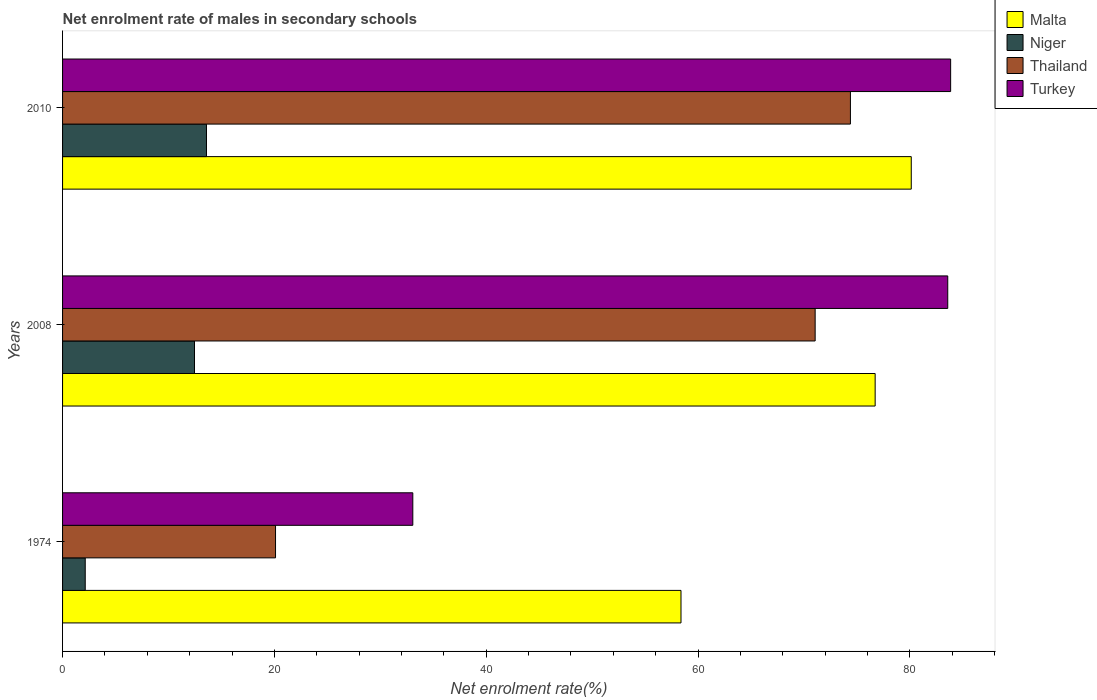How many different coloured bars are there?
Provide a succinct answer. 4. How many groups of bars are there?
Offer a very short reply. 3. Are the number of bars per tick equal to the number of legend labels?
Make the answer very short. Yes. How many bars are there on the 1st tick from the top?
Make the answer very short. 4. How many bars are there on the 2nd tick from the bottom?
Your answer should be very brief. 4. What is the label of the 3rd group of bars from the top?
Your answer should be compact. 1974. What is the net enrolment rate of males in secondary schools in Thailand in 2010?
Ensure brevity in your answer.  74.39. Across all years, what is the maximum net enrolment rate of males in secondary schools in Turkey?
Provide a short and direct response. 83.85. Across all years, what is the minimum net enrolment rate of males in secondary schools in Thailand?
Provide a short and direct response. 20.11. In which year was the net enrolment rate of males in secondary schools in Malta minimum?
Give a very brief answer. 1974. What is the total net enrolment rate of males in secondary schools in Turkey in the graph?
Keep it short and to the point. 200.51. What is the difference between the net enrolment rate of males in secondary schools in Thailand in 2008 and that in 2010?
Offer a terse response. -3.33. What is the difference between the net enrolment rate of males in secondary schools in Malta in 2010 and the net enrolment rate of males in secondary schools in Niger in 1974?
Give a very brief answer. 78. What is the average net enrolment rate of males in secondary schools in Malta per year?
Your answer should be compact. 71.75. In the year 1974, what is the difference between the net enrolment rate of males in secondary schools in Thailand and net enrolment rate of males in secondary schools in Malta?
Give a very brief answer. -38.29. In how many years, is the net enrolment rate of males in secondary schools in Malta greater than 8 %?
Offer a very short reply. 3. What is the ratio of the net enrolment rate of males in secondary schools in Thailand in 2008 to that in 2010?
Your answer should be very brief. 0.96. Is the net enrolment rate of males in secondary schools in Malta in 1974 less than that in 2008?
Provide a succinct answer. Yes. Is the difference between the net enrolment rate of males in secondary schools in Thailand in 1974 and 2008 greater than the difference between the net enrolment rate of males in secondary schools in Malta in 1974 and 2008?
Make the answer very short. No. What is the difference between the highest and the second highest net enrolment rate of males in secondary schools in Thailand?
Provide a succinct answer. 3.33. What is the difference between the highest and the lowest net enrolment rate of males in secondary schools in Turkey?
Your answer should be very brief. 50.78. Is the sum of the net enrolment rate of males in secondary schools in Niger in 1974 and 2008 greater than the maximum net enrolment rate of males in secondary schools in Turkey across all years?
Ensure brevity in your answer.  No. What does the 2nd bar from the top in 2010 represents?
Keep it short and to the point. Thailand. What does the 2nd bar from the bottom in 1974 represents?
Offer a very short reply. Niger. Is it the case that in every year, the sum of the net enrolment rate of males in secondary schools in Thailand and net enrolment rate of males in secondary schools in Turkey is greater than the net enrolment rate of males in secondary schools in Malta?
Provide a succinct answer. No. Are all the bars in the graph horizontal?
Offer a terse response. Yes. What is the difference between two consecutive major ticks on the X-axis?
Give a very brief answer. 20. Are the values on the major ticks of X-axis written in scientific E-notation?
Provide a succinct answer. No. Does the graph contain any zero values?
Offer a very short reply. No. Where does the legend appear in the graph?
Make the answer very short. Top right. What is the title of the graph?
Provide a short and direct response. Net enrolment rate of males in secondary schools. Does "Equatorial Guinea" appear as one of the legend labels in the graph?
Offer a terse response. No. What is the label or title of the X-axis?
Your answer should be very brief. Net enrolment rate(%). What is the Net enrolment rate(%) of Malta in 1974?
Offer a very short reply. 58.39. What is the Net enrolment rate(%) in Niger in 1974?
Offer a terse response. 2.14. What is the Net enrolment rate(%) of Thailand in 1974?
Provide a succinct answer. 20.11. What is the Net enrolment rate(%) of Turkey in 1974?
Offer a very short reply. 33.07. What is the Net enrolment rate(%) in Malta in 2008?
Your answer should be very brief. 76.73. What is the Net enrolment rate(%) in Niger in 2008?
Your response must be concise. 12.46. What is the Net enrolment rate(%) in Thailand in 2008?
Offer a very short reply. 71.06. What is the Net enrolment rate(%) of Turkey in 2008?
Provide a succinct answer. 83.58. What is the Net enrolment rate(%) in Malta in 2010?
Ensure brevity in your answer.  80.14. What is the Net enrolment rate(%) of Niger in 2010?
Make the answer very short. 13.59. What is the Net enrolment rate(%) in Thailand in 2010?
Make the answer very short. 74.39. What is the Net enrolment rate(%) in Turkey in 2010?
Provide a short and direct response. 83.85. Across all years, what is the maximum Net enrolment rate(%) in Malta?
Give a very brief answer. 80.14. Across all years, what is the maximum Net enrolment rate(%) in Niger?
Keep it short and to the point. 13.59. Across all years, what is the maximum Net enrolment rate(%) in Thailand?
Provide a short and direct response. 74.39. Across all years, what is the maximum Net enrolment rate(%) in Turkey?
Your answer should be compact. 83.85. Across all years, what is the minimum Net enrolment rate(%) of Malta?
Give a very brief answer. 58.39. Across all years, what is the minimum Net enrolment rate(%) of Niger?
Ensure brevity in your answer.  2.14. Across all years, what is the minimum Net enrolment rate(%) of Thailand?
Your answer should be very brief. 20.11. Across all years, what is the minimum Net enrolment rate(%) of Turkey?
Offer a very short reply. 33.07. What is the total Net enrolment rate(%) of Malta in the graph?
Your response must be concise. 215.26. What is the total Net enrolment rate(%) of Niger in the graph?
Make the answer very short. 28.19. What is the total Net enrolment rate(%) of Thailand in the graph?
Make the answer very short. 165.56. What is the total Net enrolment rate(%) of Turkey in the graph?
Your answer should be very brief. 200.51. What is the difference between the Net enrolment rate(%) of Malta in 1974 and that in 2008?
Give a very brief answer. -18.33. What is the difference between the Net enrolment rate(%) of Niger in 1974 and that in 2008?
Your response must be concise. -10.32. What is the difference between the Net enrolment rate(%) of Thailand in 1974 and that in 2008?
Offer a very short reply. -50.95. What is the difference between the Net enrolment rate(%) of Turkey in 1974 and that in 2008?
Your answer should be compact. -50.51. What is the difference between the Net enrolment rate(%) in Malta in 1974 and that in 2010?
Keep it short and to the point. -21.74. What is the difference between the Net enrolment rate(%) of Niger in 1974 and that in 2010?
Offer a terse response. -11.45. What is the difference between the Net enrolment rate(%) in Thailand in 1974 and that in 2010?
Provide a succinct answer. -54.28. What is the difference between the Net enrolment rate(%) of Turkey in 1974 and that in 2010?
Give a very brief answer. -50.78. What is the difference between the Net enrolment rate(%) of Malta in 2008 and that in 2010?
Ensure brevity in your answer.  -3.41. What is the difference between the Net enrolment rate(%) of Niger in 2008 and that in 2010?
Your response must be concise. -1.13. What is the difference between the Net enrolment rate(%) of Thailand in 2008 and that in 2010?
Keep it short and to the point. -3.33. What is the difference between the Net enrolment rate(%) of Turkey in 2008 and that in 2010?
Provide a short and direct response. -0.27. What is the difference between the Net enrolment rate(%) in Malta in 1974 and the Net enrolment rate(%) in Niger in 2008?
Offer a terse response. 45.94. What is the difference between the Net enrolment rate(%) of Malta in 1974 and the Net enrolment rate(%) of Thailand in 2008?
Keep it short and to the point. -12.67. What is the difference between the Net enrolment rate(%) of Malta in 1974 and the Net enrolment rate(%) of Turkey in 2008?
Your answer should be compact. -25.19. What is the difference between the Net enrolment rate(%) in Niger in 1974 and the Net enrolment rate(%) in Thailand in 2008?
Make the answer very short. -68.92. What is the difference between the Net enrolment rate(%) of Niger in 1974 and the Net enrolment rate(%) of Turkey in 2008?
Provide a succinct answer. -81.44. What is the difference between the Net enrolment rate(%) in Thailand in 1974 and the Net enrolment rate(%) in Turkey in 2008?
Make the answer very short. -63.47. What is the difference between the Net enrolment rate(%) of Malta in 1974 and the Net enrolment rate(%) of Niger in 2010?
Make the answer very short. 44.81. What is the difference between the Net enrolment rate(%) in Malta in 1974 and the Net enrolment rate(%) in Thailand in 2010?
Your response must be concise. -16. What is the difference between the Net enrolment rate(%) of Malta in 1974 and the Net enrolment rate(%) of Turkey in 2010?
Make the answer very short. -25.46. What is the difference between the Net enrolment rate(%) of Niger in 1974 and the Net enrolment rate(%) of Thailand in 2010?
Give a very brief answer. -72.25. What is the difference between the Net enrolment rate(%) in Niger in 1974 and the Net enrolment rate(%) in Turkey in 2010?
Make the answer very short. -81.71. What is the difference between the Net enrolment rate(%) in Thailand in 1974 and the Net enrolment rate(%) in Turkey in 2010?
Provide a short and direct response. -63.75. What is the difference between the Net enrolment rate(%) in Malta in 2008 and the Net enrolment rate(%) in Niger in 2010?
Keep it short and to the point. 63.14. What is the difference between the Net enrolment rate(%) of Malta in 2008 and the Net enrolment rate(%) of Thailand in 2010?
Your response must be concise. 2.33. What is the difference between the Net enrolment rate(%) in Malta in 2008 and the Net enrolment rate(%) in Turkey in 2010?
Give a very brief answer. -7.13. What is the difference between the Net enrolment rate(%) in Niger in 2008 and the Net enrolment rate(%) in Thailand in 2010?
Give a very brief answer. -61.94. What is the difference between the Net enrolment rate(%) in Niger in 2008 and the Net enrolment rate(%) in Turkey in 2010?
Provide a short and direct response. -71.4. What is the difference between the Net enrolment rate(%) of Thailand in 2008 and the Net enrolment rate(%) of Turkey in 2010?
Your response must be concise. -12.79. What is the average Net enrolment rate(%) of Malta per year?
Ensure brevity in your answer.  71.75. What is the average Net enrolment rate(%) of Niger per year?
Keep it short and to the point. 9.4. What is the average Net enrolment rate(%) in Thailand per year?
Make the answer very short. 55.19. What is the average Net enrolment rate(%) of Turkey per year?
Offer a very short reply. 66.84. In the year 1974, what is the difference between the Net enrolment rate(%) of Malta and Net enrolment rate(%) of Niger?
Offer a terse response. 56.25. In the year 1974, what is the difference between the Net enrolment rate(%) in Malta and Net enrolment rate(%) in Thailand?
Give a very brief answer. 38.29. In the year 1974, what is the difference between the Net enrolment rate(%) in Malta and Net enrolment rate(%) in Turkey?
Make the answer very short. 25.32. In the year 1974, what is the difference between the Net enrolment rate(%) in Niger and Net enrolment rate(%) in Thailand?
Make the answer very short. -17.97. In the year 1974, what is the difference between the Net enrolment rate(%) in Niger and Net enrolment rate(%) in Turkey?
Make the answer very short. -30.93. In the year 1974, what is the difference between the Net enrolment rate(%) in Thailand and Net enrolment rate(%) in Turkey?
Offer a very short reply. -12.96. In the year 2008, what is the difference between the Net enrolment rate(%) in Malta and Net enrolment rate(%) in Niger?
Offer a very short reply. 64.27. In the year 2008, what is the difference between the Net enrolment rate(%) in Malta and Net enrolment rate(%) in Thailand?
Your answer should be compact. 5.66. In the year 2008, what is the difference between the Net enrolment rate(%) of Malta and Net enrolment rate(%) of Turkey?
Your response must be concise. -6.86. In the year 2008, what is the difference between the Net enrolment rate(%) of Niger and Net enrolment rate(%) of Thailand?
Provide a short and direct response. -58.6. In the year 2008, what is the difference between the Net enrolment rate(%) in Niger and Net enrolment rate(%) in Turkey?
Give a very brief answer. -71.13. In the year 2008, what is the difference between the Net enrolment rate(%) of Thailand and Net enrolment rate(%) of Turkey?
Provide a succinct answer. -12.52. In the year 2010, what is the difference between the Net enrolment rate(%) of Malta and Net enrolment rate(%) of Niger?
Provide a short and direct response. 66.55. In the year 2010, what is the difference between the Net enrolment rate(%) of Malta and Net enrolment rate(%) of Thailand?
Keep it short and to the point. 5.75. In the year 2010, what is the difference between the Net enrolment rate(%) in Malta and Net enrolment rate(%) in Turkey?
Your answer should be compact. -3.72. In the year 2010, what is the difference between the Net enrolment rate(%) in Niger and Net enrolment rate(%) in Thailand?
Provide a short and direct response. -60.8. In the year 2010, what is the difference between the Net enrolment rate(%) in Niger and Net enrolment rate(%) in Turkey?
Offer a very short reply. -70.27. In the year 2010, what is the difference between the Net enrolment rate(%) of Thailand and Net enrolment rate(%) of Turkey?
Your answer should be very brief. -9.46. What is the ratio of the Net enrolment rate(%) in Malta in 1974 to that in 2008?
Make the answer very short. 0.76. What is the ratio of the Net enrolment rate(%) in Niger in 1974 to that in 2008?
Offer a very short reply. 0.17. What is the ratio of the Net enrolment rate(%) of Thailand in 1974 to that in 2008?
Ensure brevity in your answer.  0.28. What is the ratio of the Net enrolment rate(%) in Turkey in 1974 to that in 2008?
Your response must be concise. 0.4. What is the ratio of the Net enrolment rate(%) of Malta in 1974 to that in 2010?
Your response must be concise. 0.73. What is the ratio of the Net enrolment rate(%) in Niger in 1974 to that in 2010?
Your response must be concise. 0.16. What is the ratio of the Net enrolment rate(%) in Thailand in 1974 to that in 2010?
Make the answer very short. 0.27. What is the ratio of the Net enrolment rate(%) in Turkey in 1974 to that in 2010?
Your answer should be very brief. 0.39. What is the ratio of the Net enrolment rate(%) of Malta in 2008 to that in 2010?
Your response must be concise. 0.96. What is the ratio of the Net enrolment rate(%) in Niger in 2008 to that in 2010?
Offer a terse response. 0.92. What is the ratio of the Net enrolment rate(%) in Thailand in 2008 to that in 2010?
Offer a terse response. 0.96. What is the ratio of the Net enrolment rate(%) in Turkey in 2008 to that in 2010?
Give a very brief answer. 1. What is the difference between the highest and the second highest Net enrolment rate(%) of Malta?
Give a very brief answer. 3.41. What is the difference between the highest and the second highest Net enrolment rate(%) of Niger?
Make the answer very short. 1.13. What is the difference between the highest and the second highest Net enrolment rate(%) of Thailand?
Make the answer very short. 3.33. What is the difference between the highest and the second highest Net enrolment rate(%) of Turkey?
Your answer should be very brief. 0.27. What is the difference between the highest and the lowest Net enrolment rate(%) in Malta?
Ensure brevity in your answer.  21.74. What is the difference between the highest and the lowest Net enrolment rate(%) of Niger?
Offer a very short reply. 11.45. What is the difference between the highest and the lowest Net enrolment rate(%) of Thailand?
Provide a short and direct response. 54.28. What is the difference between the highest and the lowest Net enrolment rate(%) of Turkey?
Keep it short and to the point. 50.78. 